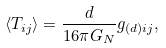<formula> <loc_0><loc_0><loc_500><loc_500>\langle T _ { i j } \rangle = \frac { d } { 1 6 \pi G _ { N } } g _ { ( d ) i j } ,</formula> 